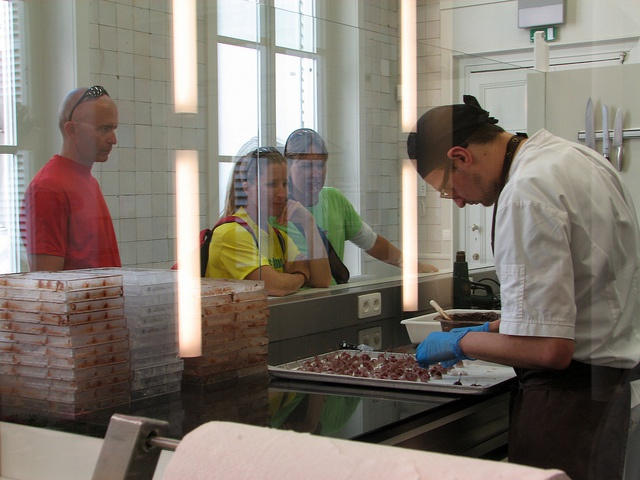Describe the objects in this image and their specific colors. I can see people in white, black, gray, darkgray, and maroon tones, people in white, maroon, and brown tones, chair in white, lightgray, black, and gray tones, people in white, olive, gray, and maroon tones, and people in white, gray, darkgreen, green, and maroon tones in this image. 